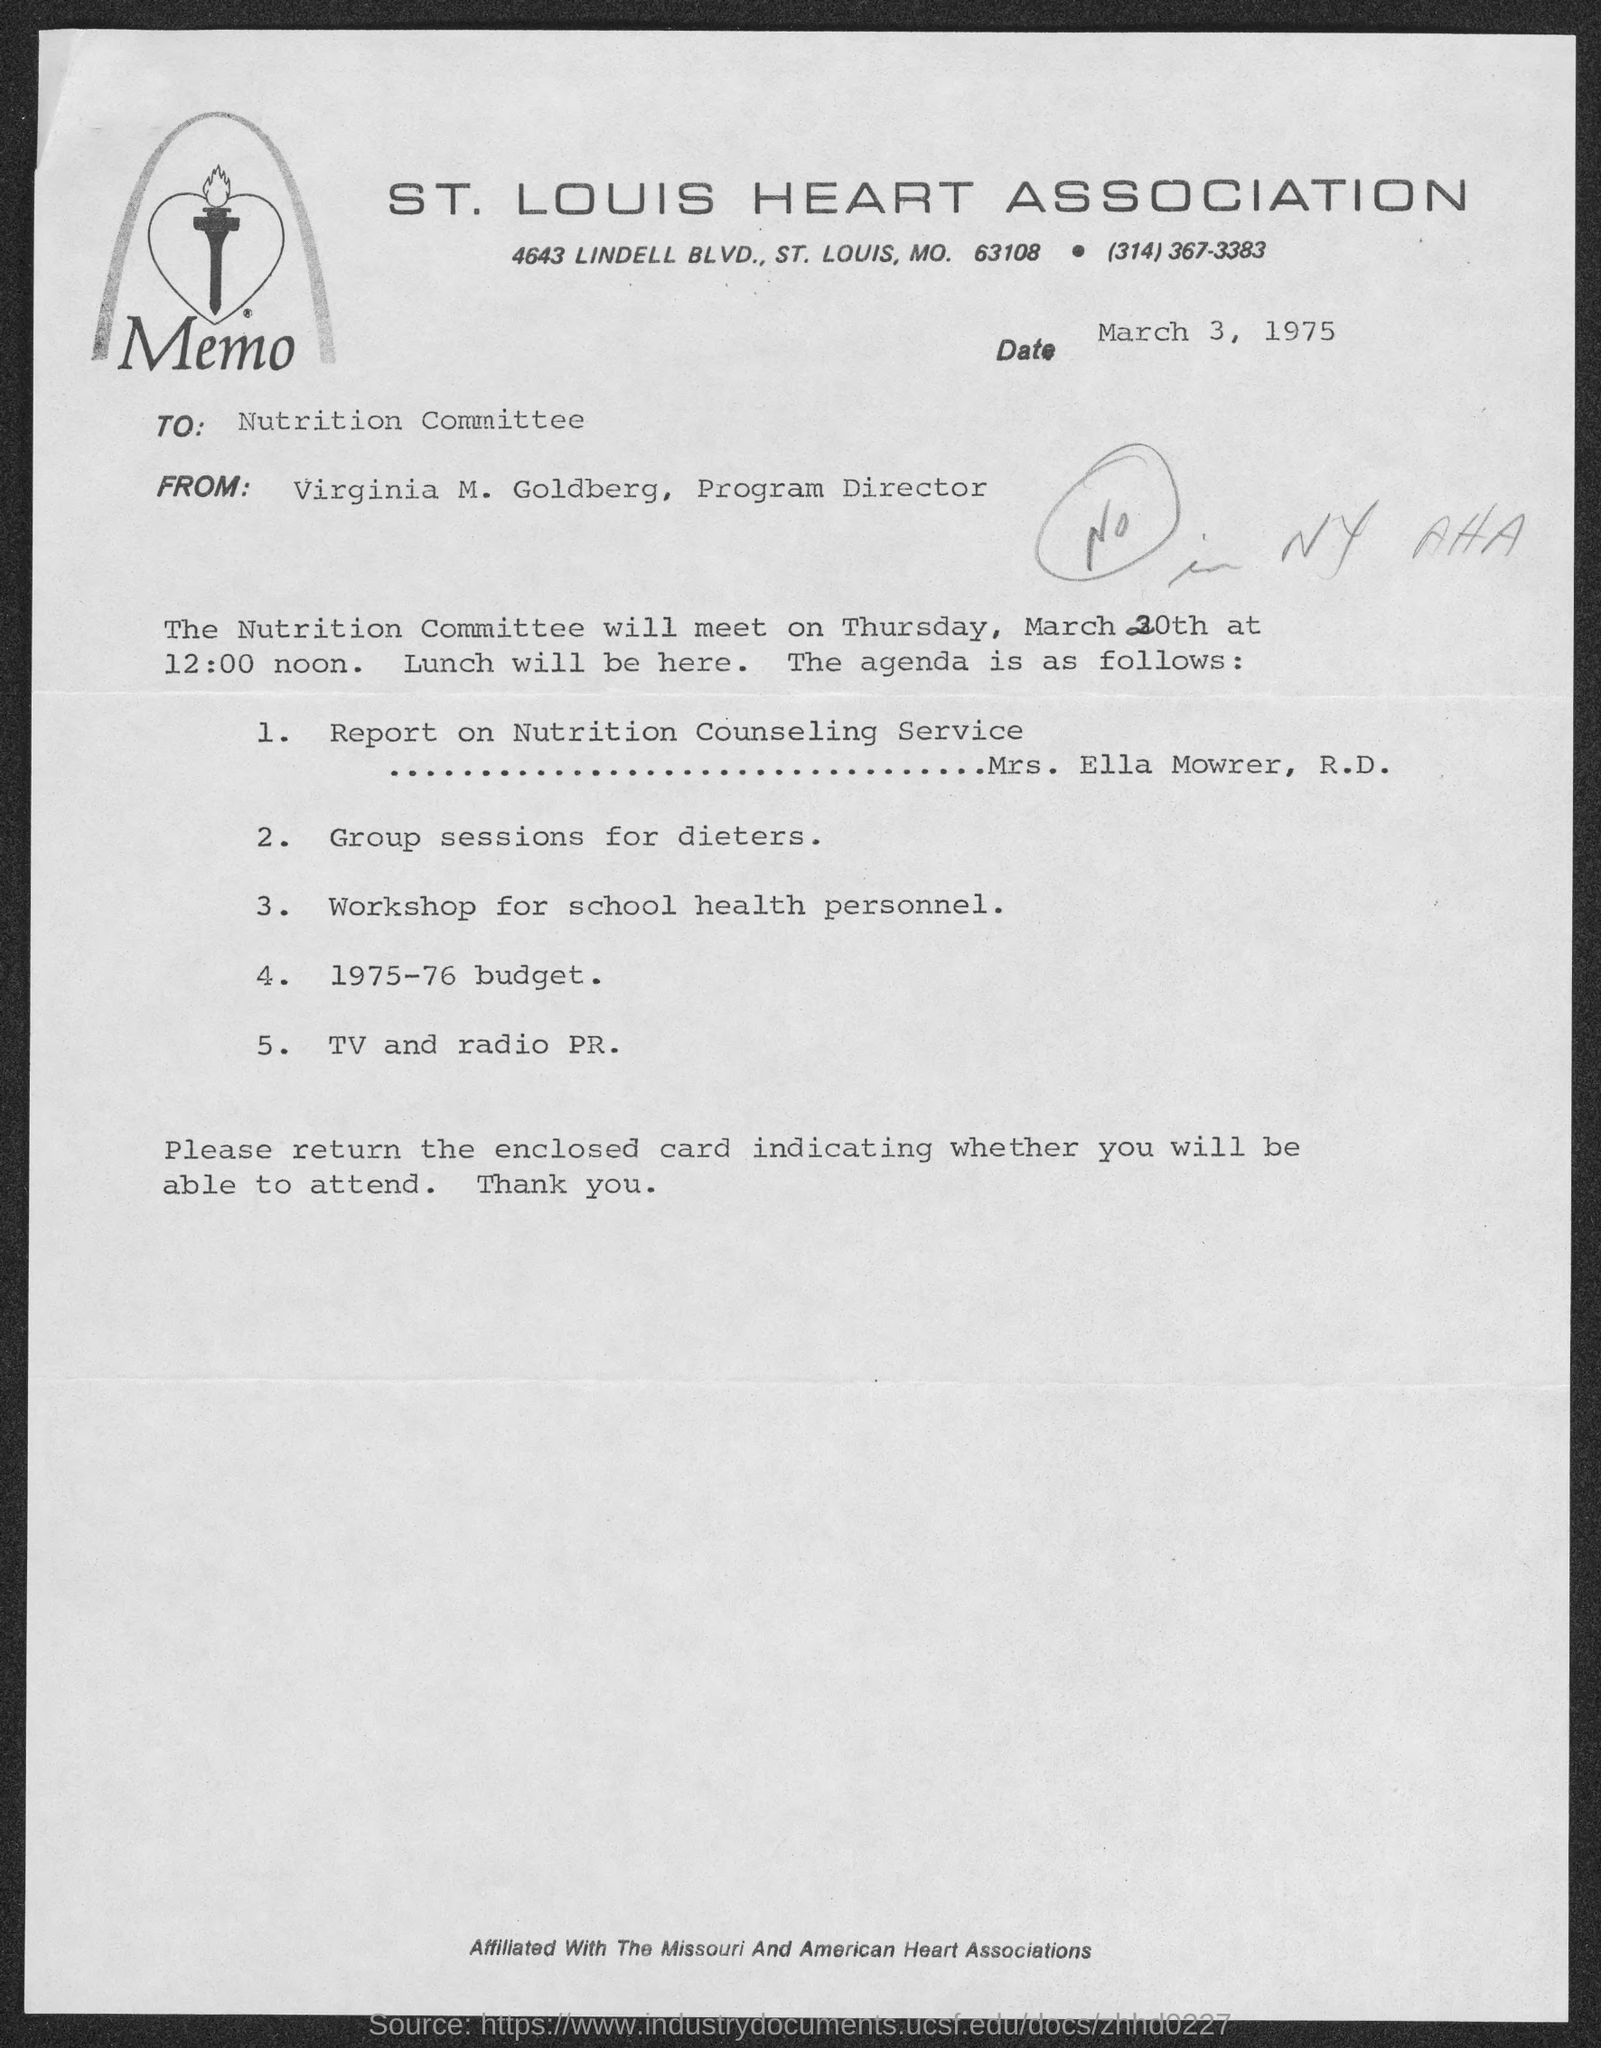Which Association is mentioned in the letterhead?
Give a very brief answer. St. Louis Heart Association. What is the issued date of this memo?
Make the answer very short. March 3, 1975. To whom, the memo is addressed?
Provide a short and direct response. Nutrition Committee. Who is the sender of this memo?
Ensure brevity in your answer.  Virginia M. Goldberg. Who is presenting the report on Nutrition Counseling Service as given in the agenda?
Your answer should be very brief. Mrs. Ella Mowrer, R.D. 